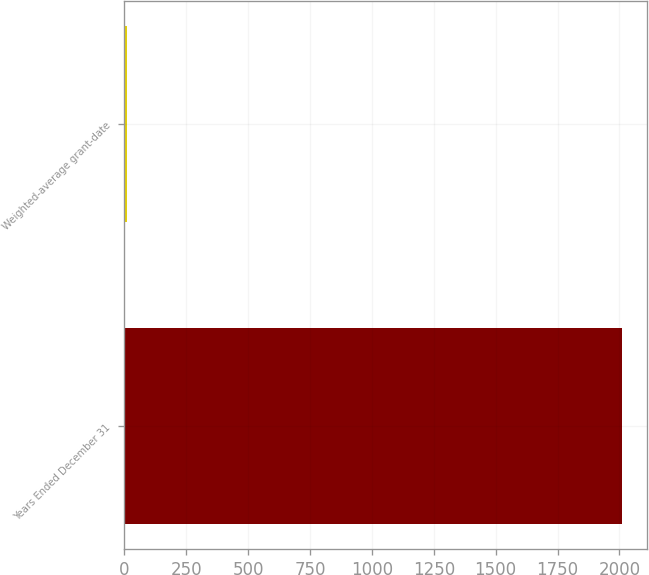<chart> <loc_0><loc_0><loc_500><loc_500><bar_chart><fcel>Years Ended December 31<fcel>Weighted-average grant-date<nl><fcel>2012<fcel>12.32<nl></chart> 